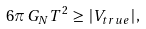<formula> <loc_0><loc_0><loc_500><loc_500>6 \pi \, G _ { N } T ^ { 2 } \, \geq \, | V _ { t r u e } | \, ,</formula> 